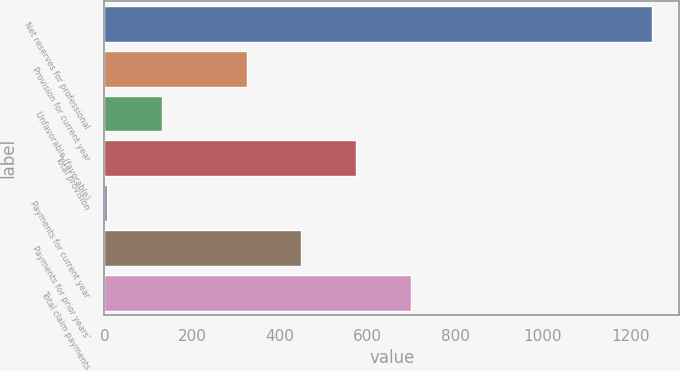Convert chart to OTSL. <chart><loc_0><loc_0><loc_500><loc_500><bar_chart><fcel>Net reserves for professional<fcel>Provision for current year<fcel>Unfavorable (favorable)<fcel>Total provision<fcel>Payments for current year<fcel>Payments for prior years'<fcel>Total claim payments<nl><fcel>1248<fcel>324<fcel>130.6<fcel>573.2<fcel>6<fcel>448.6<fcel>697.8<nl></chart> 